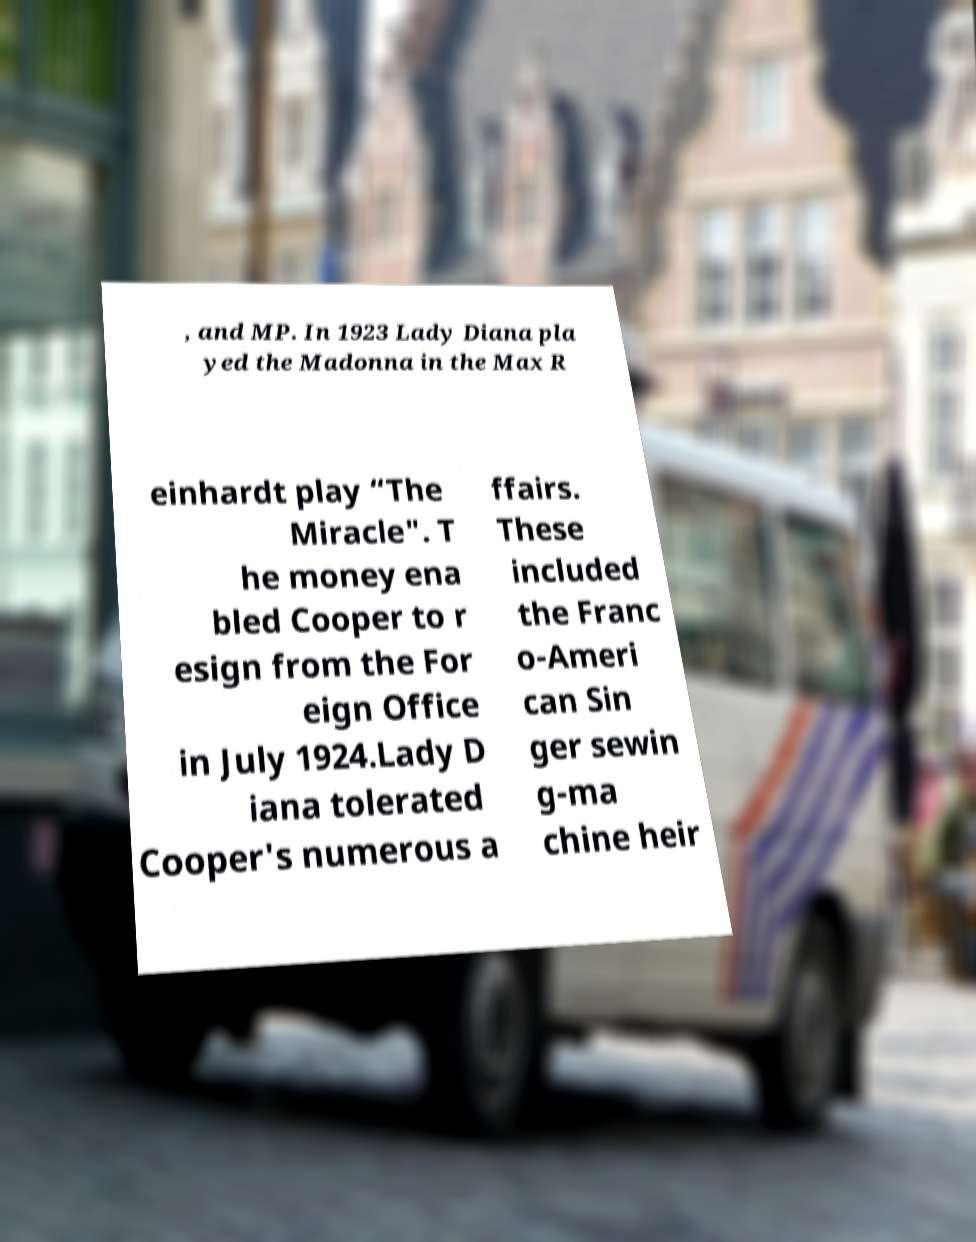Can you accurately transcribe the text from the provided image for me? , and MP. In 1923 Lady Diana pla yed the Madonna in the Max R einhardt play “The Miracle". T he money ena bled Cooper to r esign from the For eign Office in July 1924.Lady D iana tolerated Cooper's numerous a ffairs. These included the Franc o-Ameri can Sin ger sewin g-ma chine heir 